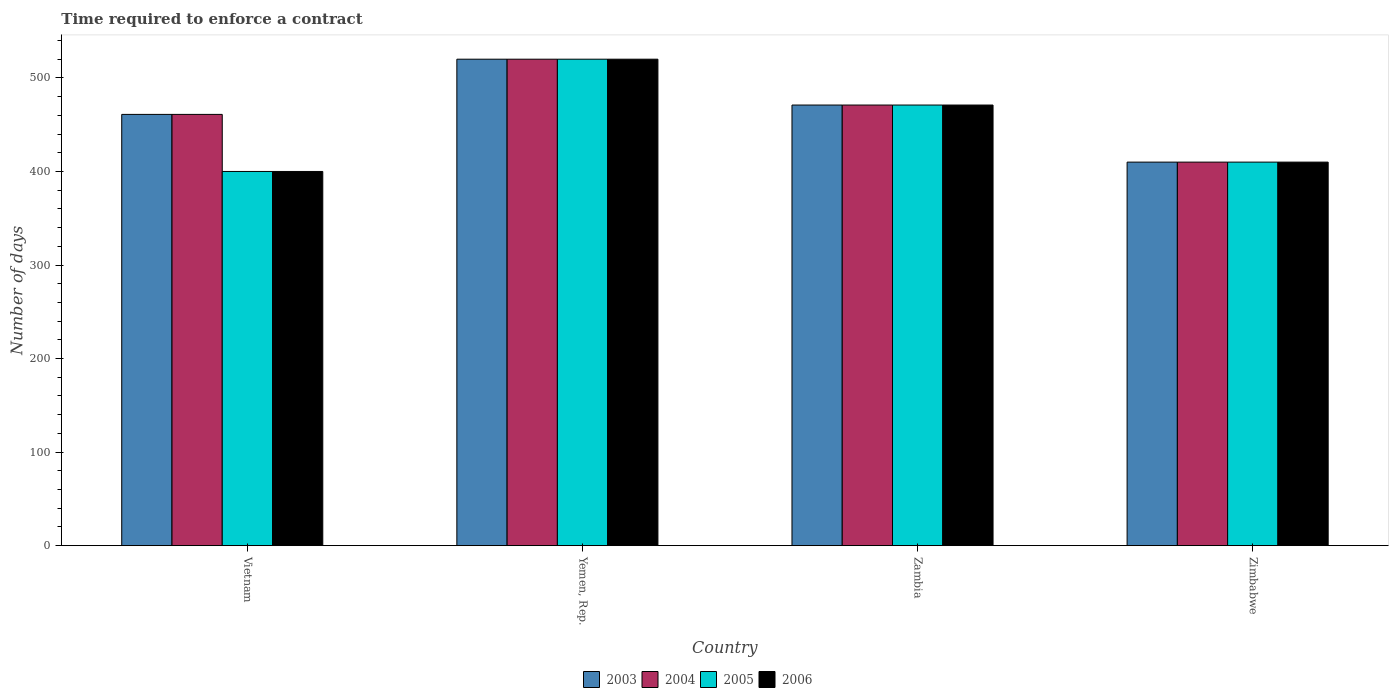How many different coloured bars are there?
Offer a very short reply. 4. How many groups of bars are there?
Provide a succinct answer. 4. Are the number of bars per tick equal to the number of legend labels?
Offer a very short reply. Yes. How many bars are there on the 3rd tick from the left?
Offer a terse response. 4. What is the label of the 2nd group of bars from the left?
Make the answer very short. Yemen, Rep. What is the number of days required to enforce a contract in 2006 in Zimbabwe?
Make the answer very short. 410. Across all countries, what is the maximum number of days required to enforce a contract in 2003?
Provide a succinct answer. 520. Across all countries, what is the minimum number of days required to enforce a contract in 2003?
Offer a terse response. 410. In which country was the number of days required to enforce a contract in 2003 maximum?
Offer a very short reply. Yemen, Rep. In which country was the number of days required to enforce a contract in 2004 minimum?
Your response must be concise. Zimbabwe. What is the total number of days required to enforce a contract in 2005 in the graph?
Make the answer very short. 1801. What is the difference between the number of days required to enforce a contract in 2003 in Vietnam and that in Zimbabwe?
Ensure brevity in your answer.  51. What is the difference between the number of days required to enforce a contract in 2004 in Zimbabwe and the number of days required to enforce a contract in 2003 in Vietnam?
Offer a terse response. -51. What is the average number of days required to enforce a contract in 2003 per country?
Your answer should be very brief. 465.5. In how many countries, is the number of days required to enforce a contract in 2003 greater than 40 days?
Ensure brevity in your answer.  4. What is the ratio of the number of days required to enforce a contract in 2003 in Yemen, Rep. to that in Zimbabwe?
Offer a terse response. 1.27. What is the difference between the highest and the lowest number of days required to enforce a contract in 2005?
Make the answer very short. 120. In how many countries, is the number of days required to enforce a contract in 2006 greater than the average number of days required to enforce a contract in 2006 taken over all countries?
Your answer should be compact. 2. Is it the case that in every country, the sum of the number of days required to enforce a contract in 2006 and number of days required to enforce a contract in 2005 is greater than the sum of number of days required to enforce a contract in 2004 and number of days required to enforce a contract in 2003?
Your response must be concise. No. What does the 3rd bar from the right in Zimbabwe represents?
Give a very brief answer. 2004. Is it the case that in every country, the sum of the number of days required to enforce a contract in 2006 and number of days required to enforce a contract in 2004 is greater than the number of days required to enforce a contract in 2005?
Your answer should be very brief. Yes. How many bars are there?
Make the answer very short. 16. Are all the bars in the graph horizontal?
Your response must be concise. No. Does the graph contain grids?
Your answer should be compact. No. Where does the legend appear in the graph?
Offer a very short reply. Bottom center. How many legend labels are there?
Make the answer very short. 4. How are the legend labels stacked?
Your response must be concise. Horizontal. What is the title of the graph?
Your answer should be very brief. Time required to enforce a contract. Does "1970" appear as one of the legend labels in the graph?
Give a very brief answer. No. What is the label or title of the X-axis?
Give a very brief answer. Country. What is the label or title of the Y-axis?
Your answer should be compact. Number of days. What is the Number of days of 2003 in Vietnam?
Give a very brief answer. 461. What is the Number of days of 2004 in Vietnam?
Ensure brevity in your answer.  461. What is the Number of days in 2005 in Vietnam?
Ensure brevity in your answer.  400. What is the Number of days of 2006 in Vietnam?
Give a very brief answer. 400. What is the Number of days in 2003 in Yemen, Rep.?
Offer a terse response. 520. What is the Number of days of 2004 in Yemen, Rep.?
Your response must be concise. 520. What is the Number of days of 2005 in Yemen, Rep.?
Make the answer very short. 520. What is the Number of days in 2006 in Yemen, Rep.?
Make the answer very short. 520. What is the Number of days in 2003 in Zambia?
Offer a very short reply. 471. What is the Number of days in 2004 in Zambia?
Ensure brevity in your answer.  471. What is the Number of days in 2005 in Zambia?
Give a very brief answer. 471. What is the Number of days of 2006 in Zambia?
Make the answer very short. 471. What is the Number of days of 2003 in Zimbabwe?
Make the answer very short. 410. What is the Number of days in 2004 in Zimbabwe?
Your answer should be very brief. 410. What is the Number of days of 2005 in Zimbabwe?
Provide a short and direct response. 410. What is the Number of days in 2006 in Zimbabwe?
Keep it short and to the point. 410. Across all countries, what is the maximum Number of days of 2003?
Your answer should be very brief. 520. Across all countries, what is the maximum Number of days of 2004?
Your answer should be very brief. 520. Across all countries, what is the maximum Number of days of 2005?
Offer a very short reply. 520. Across all countries, what is the maximum Number of days in 2006?
Offer a terse response. 520. Across all countries, what is the minimum Number of days of 2003?
Give a very brief answer. 410. Across all countries, what is the minimum Number of days of 2004?
Offer a very short reply. 410. Across all countries, what is the minimum Number of days in 2005?
Offer a terse response. 400. Across all countries, what is the minimum Number of days in 2006?
Make the answer very short. 400. What is the total Number of days of 2003 in the graph?
Offer a terse response. 1862. What is the total Number of days of 2004 in the graph?
Your response must be concise. 1862. What is the total Number of days in 2005 in the graph?
Offer a very short reply. 1801. What is the total Number of days in 2006 in the graph?
Provide a succinct answer. 1801. What is the difference between the Number of days in 2003 in Vietnam and that in Yemen, Rep.?
Offer a very short reply. -59. What is the difference between the Number of days in 2004 in Vietnam and that in Yemen, Rep.?
Make the answer very short. -59. What is the difference between the Number of days in 2005 in Vietnam and that in Yemen, Rep.?
Provide a short and direct response. -120. What is the difference between the Number of days of 2006 in Vietnam and that in Yemen, Rep.?
Offer a very short reply. -120. What is the difference between the Number of days of 2004 in Vietnam and that in Zambia?
Your response must be concise. -10. What is the difference between the Number of days of 2005 in Vietnam and that in Zambia?
Offer a very short reply. -71. What is the difference between the Number of days of 2006 in Vietnam and that in Zambia?
Your answer should be compact. -71. What is the difference between the Number of days in 2006 in Vietnam and that in Zimbabwe?
Provide a short and direct response. -10. What is the difference between the Number of days in 2003 in Yemen, Rep. and that in Zambia?
Offer a very short reply. 49. What is the difference between the Number of days of 2004 in Yemen, Rep. and that in Zambia?
Provide a short and direct response. 49. What is the difference between the Number of days of 2006 in Yemen, Rep. and that in Zambia?
Offer a terse response. 49. What is the difference between the Number of days of 2003 in Yemen, Rep. and that in Zimbabwe?
Offer a very short reply. 110. What is the difference between the Number of days in 2004 in Yemen, Rep. and that in Zimbabwe?
Make the answer very short. 110. What is the difference between the Number of days in 2005 in Yemen, Rep. and that in Zimbabwe?
Provide a short and direct response. 110. What is the difference between the Number of days of 2006 in Yemen, Rep. and that in Zimbabwe?
Ensure brevity in your answer.  110. What is the difference between the Number of days of 2003 in Zambia and that in Zimbabwe?
Your answer should be compact. 61. What is the difference between the Number of days of 2003 in Vietnam and the Number of days of 2004 in Yemen, Rep.?
Provide a succinct answer. -59. What is the difference between the Number of days in 2003 in Vietnam and the Number of days in 2005 in Yemen, Rep.?
Provide a short and direct response. -59. What is the difference between the Number of days in 2003 in Vietnam and the Number of days in 2006 in Yemen, Rep.?
Offer a very short reply. -59. What is the difference between the Number of days in 2004 in Vietnam and the Number of days in 2005 in Yemen, Rep.?
Ensure brevity in your answer.  -59. What is the difference between the Number of days in 2004 in Vietnam and the Number of days in 2006 in Yemen, Rep.?
Make the answer very short. -59. What is the difference between the Number of days of 2005 in Vietnam and the Number of days of 2006 in Yemen, Rep.?
Offer a terse response. -120. What is the difference between the Number of days in 2003 in Vietnam and the Number of days in 2004 in Zambia?
Offer a very short reply. -10. What is the difference between the Number of days in 2003 in Vietnam and the Number of days in 2005 in Zambia?
Offer a terse response. -10. What is the difference between the Number of days in 2005 in Vietnam and the Number of days in 2006 in Zambia?
Your response must be concise. -71. What is the difference between the Number of days of 2003 in Vietnam and the Number of days of 2005 in Zimbabwe?
Give a very brief answer. 51. What is the difference between the Number of days in 2003 in Vietnam and the Number of days in 2006 in Zimbabwe?
Ensure brevity in your answer.  51. What is the difference between the Number of days of 2004 in Vietnam and the Number of days of 2006 in Zimbabwe?
Give a very brief answer. 51. What is the difference between the Number of days in 2003 in Yemen, Rep. and the Number of days in 2005 in Zambia?
Offer a terse response. 49. What is the difference between the Number of days in 2003 in Yemen, Rep. and the Number of days in 2006 in Zambia?
Offer a terse response. 49. What is the difference between the Number of days of 2004 in Yemen, Rep. and the Number of days of 2005 in Zambia?
Give a very brief answer. 49. What is the difference between the Number of days of 2005 in Yemen, Rep. and the Number of days of 2006 in Zambia?
Offer a very short reply. 49. What is the difference between the Number of days of 2003 in Yemen, Rep. and the Number of days of 2004 in Zimbabwe?
Your answer should be very brief. 110. What is the difference between the Number of days in 2003 in Yemen, Rep. and the Number of days in 2005 in Zimbabwe?
Give a very brief answer. 110. What is the difference between the Number of days in 2003 in Yemen, Rep. and the Number of days in 2006 in Zimbabwe?
Provide a succinct answer. 110. What is the difference between the Number of days in 2004 in Yemen, Rep. and the Number of days in 2005 in Zimbabwe?
Your response must be concise. 110. What is the difference between the Number of days of 2004 in Yemen, Rep. and the Number of days of 2006 in Zimbabwe?
Your answer should be very brief. 110. What is the difference between the Number of days in 2005 in Yemen, Rep. and the Number of days in 2006 in Zimbabwe?
Keep it short and to the point. 110. What is the difference between the Number of days in 2003 in Zambia and the Number of days in 2004 in Zimbabwe?
Provide a short and direct response. 61. What is the difference between the Number of days in 2004 in Zambia and the Number of days in 2005 in Zimbabwe?
Ensure brevity in your answer.  61. What is the difference between the Number of days of 2004 in Zambia and the Number of days of 2006 in Zimbabwe?
Make the answer very short. 61. What is the average Number of days of 2003 per country?
Ensure brevity in your answer.  465.5. What is the average Number of days in 2004 per country?
Offer a very short reply. 465.5. What is the average Number of days in 2005 per country?
Your answer should be very brief. 450.25. What is the average Number of days of 2006 per country?
Ensure brevity in your answer.  450.25. What is the difference between the Number of days in 2003 and Number of days in 2006 in Vietnam?
Ensure brevity in your answer.  61. What is the difference between the Number of days in 2004 and Number of days in 2005 in Vietnam?
Provide a succinct answer. 61. What is the difference between the Number of days of 2005 and Number of days of 2006 in Vietnam?
Your answer should be compact. 0. What is the difference between the Number of days in 2003 and Number of days in 2006 in Yemen, Rep.?
Your answer should be compact. 0. What is the difference between the Number of days of 2004 and Number of days of 2006 in Yemen, Rep.?
Your response must be concise. 0. What is the difference between the Number of days of 2005 and Number of days of 2006 in Yemen, Rep.?
Ensure brevity in your answer.  0. What is the difference between the Number of days of 2003 and Number of days of 2004 in Zambia?
Offer a terse response. 0. What is the difference between the Number of days in 2003 and Number of days in 2006 in Zambia?
Your answer should be compact. 0. What is the difference between the Number of days in 2005 and Number of days in 2006 in Zambia?
Your response must be concise. 0. What is the difference between the Number of days of 2003 and Number of days of 2005 in Zimbabwe?
Your response must be concise. 0. What is the ratio of the Number of days in 2003 in Vietnam to that in Yemen, Rep.?
Your answer should be compact. 0.89. What is the ratio of the Number of days in 2004 in Vietnam to that in Yemen, Rep.?
Your response must be concise. 0.89. What is the ratio of the Number of days of 2005 in Vietnam to that in Yemen, Rep.?
Offer a very short reply. 0.77. What is the ratio of the Number of days of 2006 in Vietnam to that in Yemen, Rep.?
Keep it short and to the point. 0.77. What is the ratio of the Number of days of 2003 in Vietnam to that in Zambia?
Your response must be concise. 0.98. What is the ratio of the Number of days of 2004 in Vietnam to that in Zambia?
Provide a succinct answer. 0.98. What is the ratio of the Number of days of 2005 in Vietnam to that in Zambia?
Offer a terse response. 0.85. What is the ratio of the Number of days in 2006 in Vietnam to that in Zambia?
Your answer should be very brief. 0.85. What is the ratio of the Number of days in 2003 in Vietnam to that in Zimbabwe?
Your response must be concise. 1.12. What is the ratio of the Number of days in 2004 in Vietnam to that in Zimbabwe?
Your response must be concise. 1.12. What is the ratio of the Number of days in 2005 in Vietnam to that in Zimbabwe?
Your response must be concise. 0.98. What is the ratio of the Number of days in 2006 in Vietnam to that in Zimbabwe?
Offer a terse response. 0.98. What is the ratio of the Number of days in 2003 in Yemen, Rep. to that in Zambia?
Provide a succinct answer. 1.1. What is the ratio of the Number of days of 2004 in Yemen, Rep. to that in Zambia?
Ensure brevity in your answer.  1.1. What is the ratio of the Number of days in 2005 in Yemen, Rep. to that in Zambia?
Your response must be concise. 1.1. What is the ratio of the Number of days in 2006 in Yemen, Rep. to that in Zambia?
Your response must be concise. 1.1. What is the ratio of the Number of days in 2003 in Yemen, Rep. to that in Zimbabwe?
Your response must be concise. 1.27. What is the ratio of the Number of days of 2004 in Yemen, Rep. to that in Zimbabwe?
Make the answer very short. 1.27. What is the ratio of the Number of days of 2005 in Yemen, Rep. to that in Zimbabwe?
Provide a succinct answer. 1.27. What is the ratio of the Number of days of 2006 in Yemen, Rep. to that in Zimbabwe?
Keep it short and to the point. 1.27. What is the ratio of the Number of days in 2003 in Zambia to that in Zimbabwe?
Give a very brief answer. 1.15. What is the ratio of the Number of days of 2004 in Zambia to that in Zimbabwe?
Give a very brief answer. 1.15. What is the ratio of the Number of days in 2005 in Zambia to that in Zimbabwe?
Keep it short and to the point. 1.15. What is the ratio of the Number of days in 2006 in Zambia to that in Zimbabwe?
Your answer should be very brief. 1.15. What is the difference between the highest and the second highest Number of days in 2004?
Your answer should be compact. 49. What is the difference between the highest and the second highest Number of days of 2006?
Offer a terse response. 49. What is the difference between the highest and the lowest Number of days of 2003?
Your answer should be compact. 110. What is the difference between the highest and the lowest Number of days of 2004?
Offer a terse response. 110. What is the difference between the highest and the lowest Number of days of 2005?
Give a very brief answer. 120. What is the difference between the highest and the lowest Number of days of 2006?
Ensure brevity in your answer.  120. 